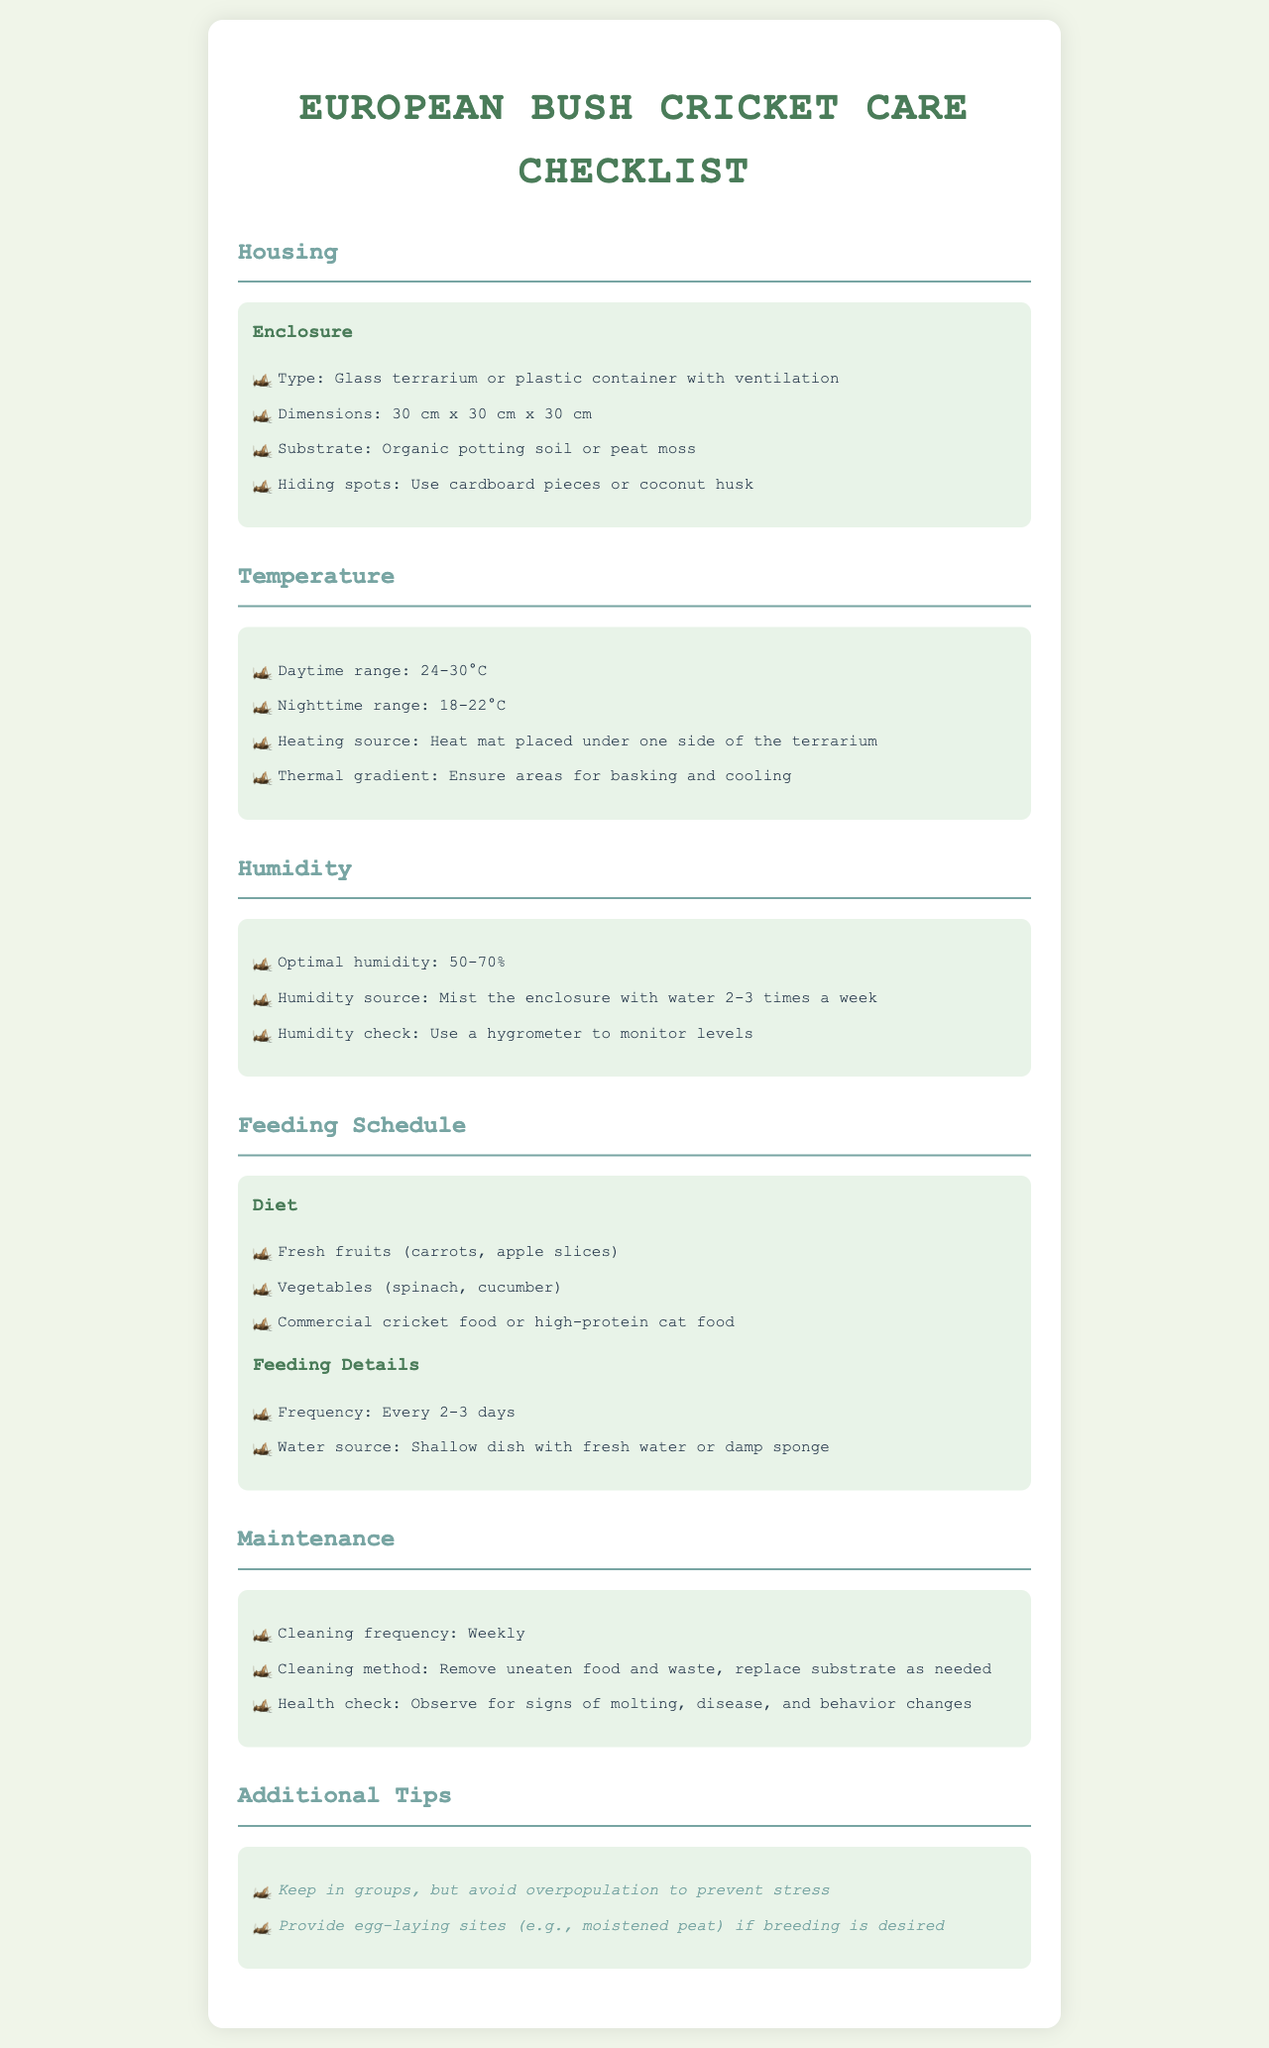What type of enclosure is recommended? The document specifies that a glass terrarium or plastic container with ventilation is suitable for housing European bush crickets.
Answer: Glass terrarium or plastic container with ventilation What is the optimal humidity range? The optimal humidity range for European bush crickets is provided in the document, which is between 50% and 70%.
Answer: 50-70% How often should you mist the enclosure? The document states that you should mist the enclosure 2-3 times a week to maintain humidity.
Answer: 2-3 times a week What is the daytime temperature range? The document specifies that the daytime temperature range should be between 24°C and 30°C for optimal care.
Answer: 24-30°C How frequently should the crickets be fed? The document mentions that European bush crickets should be fed every 2-3 days.
Answer: Every 2-3 days What is a recommended water source for the crickets? The document indicates that a shallow dish with fresh water or a damp sponge is a suitable water source for European bush crickets.
Answer: Shallow dish with fresh water or damp sponge What is the cleaning frequency suggested in the document? The document advises a cleaning frequency of weekly for the maintenance of the enclosure.
Answer: Weekly What should be observed for in a health check? The document states that the health check should involve observing for signs of molting, disease, and behavior changes.
Answer: Signs of molting, disease, and behavior changes What type of substrate is recommended? The document suggests using organic potting soil or peat moss as substrate in the enclosure.
Answer: Organic potting soil or peat moss 